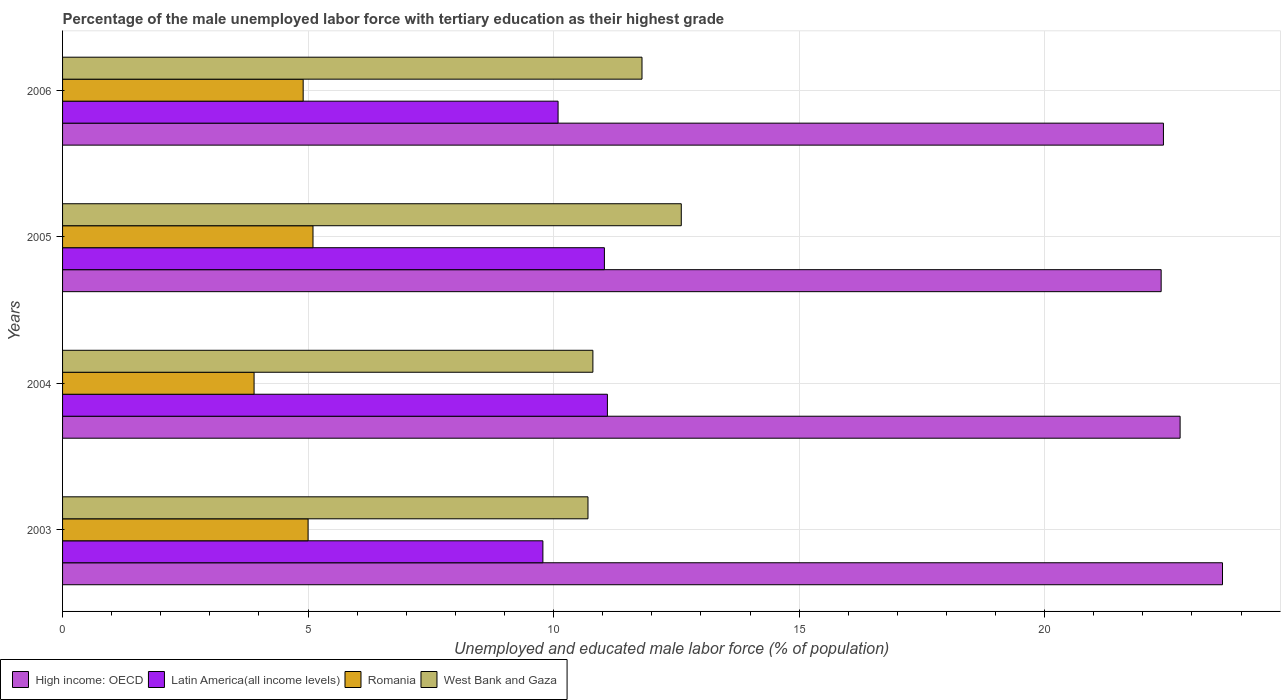How many different coloured bars are there?
Your response must be concise. 4. Are the number of bars per tick equal to the number of legend labels?
Provide a succinct answer. Yes. How many bars are there on the 1st tick from the top?
Your answer should be compact. 4. How many bars are there on the 1st tick from the bottom?
Make the answer very short. 4. What is the label of the 3rd group of bars from the top?
Offer a terse response. 2004. In how many cases, is the number of bars for a given year not equal to the number of legend labels?
Offer a terse response. 0. What is the percentage of the unemployed male labor force with tertiary education in High income: OECD in 2005?
Your answer should be compact. 22.37. Across all years, what is the maximum percentage of the unemployed male labor force with tertiary education in West Bank and Gaza?
Ensure brevity in your answer.  12.6. Across all years, what is the minimum percentage of the unemployed male labor force with tertiary education in Latin America(all income levels)?
Keep it short and to the point. 9.78. In which year was the percentage of the unemployed male labor force with tertiary education in High income: OECD minimum?
Ensure brevity in your answer.  2005. What is the total percentage of the unemployed male labor force with tertiary education in Latin America(all income levels) in the graph?
Give a very brief answer. 42. What is the difference between the percentage of the unemployed male labor force with tertiary education in West Bank and Gaza in 2003 and that in 2004?
Ensure brevity in your answer.  -0.1. What is the difference between the percentage of the unemployed male labor force with tertiary education in High income: OECD in 2004 and the percentage of the unemployed male labor force with tertiary education in West Bank and Gaza in 2005?
Your answer should be compact. 10.16. What is the average percentage of the unemployed male labor force with tertiary education in Latin America(all income levels) per year?
Make the answer very short. 10.5. In the year 2006, what is the difference between the percentage of the unemployed male labor force with tertiary education in West Bank and Gaza and percentage of the unemployed male labor force with tertiary education in High income: OECD?
Give a very brief answer. -10.62. In how many years, is the percentage of the unemployed male labor force with tertiary education in Latin America(all income levels) greater than 6 %?
Give a very brief answer. 4. What is the ratio of the percentage of the unemployed male labor force with tertiary education in Romania in 2005 to that in 2006?
Keep it short and to the point. 1.04. Is the percentage of the unemployed male labor force with tertiary education in High income: OECD in 2003 less than that in 2005?
Provide a short and direct response. No. Is the difference between the percentage of the unemployed male labor force with tertiary education in West Bank and Gaza in 2003 and 2005 greater than the difference between the percentage of the unemployed male labor force with tertiary education in High income: OECD in 2003 and 2005?
Keep it short and to the point. No. What is the difference between the highest and the second highest percentage of the unemployed male labor force with tertiary education in West Bank and Gaza?
Your response must be concise. 0.8. What is the difference between the highest and the lowest percentage of the unemployed male labor force with tertiary education in Romania?
Provide a short and direct response. 1.2. In how many years, is the percentage of the unemployed male labor force with tertiary education in High income: OECD greater than the average percentage of the unemployed male labor force with tertiary education in High income: OECD taken over all years?
Your response must be concise. 1. Is the sum of the percentage of the unemployed male labor force with tertiary education in Romania in 2003 and 2004 greater than the maximum percentage of the unemployed male labor force with tertiary education in Latin America(all income levels) across all years?
Your response must be concise. No. Is it the case that in every year, the sum of the percentage of the unemployed male labor force with tertiary education in Latin America(all income levels) and percentage of the unemployed male labor force with tertiary education in High income: OECD is greater than the sum of percentage of the unemployed male labor force with tertiary education in Romania and percentage of the unemployed male labor force with tertiary education in West Bank and Gaza?
Provide a short and direct response. No. What does the 3rd bar from the top in 2003 represents?
Give a very brief answer. Latin America(all income levels). What does the 2nd bar from the bottom in 2003 represents?
Ensure brevity in your answer.  Latin America(all income levels). Is it the case that in every year, the sum of the percentage of the unemployed male labor force with tertiary education in Romania and percentage of the unemployed male labor force with tertiary education in High income: OECD is greater than the percentage of the unemployed male labor force with tertiary education in Latin America(all income levels)?
Your response must be concise. Yes. Are all the bars in the graph horizontal?
Make the answer very short. Yes. How many years are there in the graph?
Keep it short and to the point. 4. What is the difference between two consecutive major ticks on the X-axis?
Provide a succinct answer. 5. Are the values on the major ticks of X-axis written in scientific E-notation?
Ensure brevity in your answer.  No. Does the graph contain any zero values?
Offer a terse response. No. Does the graph contain grids?
Offer a terse response. Yes. What is the title of the graph?
Make the answer very short. Percentage of the male unemployed labor force with tertiary education as their highest grade. Does "Sub-Saharan Africa (all income levels)" appear as one of the legend labels in the graph?
Your answer should be very brief. No. What is the label or title of the X-axis?
Keep it short and to the point. Unemployed and educated male labor force (% of population). What is the label or title of the Y-axis?
Ensure brevity in your answer.  Years. What is the Unemployed and educated male labor force (% of population) in High income: OECD in 2003?
Offer a very short reply. 23.62. What is the Unemployed and educated male labor force (% of population) in Latin America(all income levels) in 2003?
Keep it short and to the point. 9.78. What is the Unemployed and educated male labor force (% of population) in West Bank and Gaza in 2003?
Offer a terse response. 10.7. What is the Unemployed and educated male labor force (% of population) in High income: OECD in 2004?
Offer a terse response. 22.76. What is the Unemployed and educated male labor force (% of population) of Latin America(all income levels) in 2004?
Your answer should be very brief. 11.1. What is the Unemployed and educated male labor force (% of population) of Romania in 2004?
Your answer should be compact. 3.9. What is the Unemployed and educated male labor force (% of population) of West Bank and Gaza in 2004?
Your response must be concise. 10.8. What is the Unemployed and educated male labor force (% of population) in High income: OECD in 2005?
Provide a short and direct response. 22.37. What is the Unemployed and educated male labor force (% of population) in Latin America(all income levels) in 2005?
Give a very brief answer. 11.03. What is the Unemployed and educated male labor force (% of population) in Romania in 2005?
Your answer should be compact. 5.1. What is the Unemployed and educated male labor force (% of population) in West Bank and Gaza in 2005?
Your answer should be very brief. 12.6. What is the Unemployed and educated male labor force (% of population) of High income: OECD in 2006?
Provide a short and direct response. 22.42. What is the Unemployed and educated male labor force (% of population) in Latin America(all income levels) in 2006?
Ensure brevity in your answer.  10.09. What is the Unemployed and educated male labor force (% of population) in Romania in 2006?
Provide a short and direct response. 4.9. What is the Unemployed and educated male labor force (% of population) in West Bank and Gaza in 2006?
Offer a very short reply. 11.8. Across all years, what is the maximum Unemployed and educated male labor force (% of population) of High income: OECD?
Offer a very short reply. 23.62. Across all years, what is the maximum Unemployed and educated male labor force (% of population) in Latin America(all income levels)?
Your response must be concise. 11.1. Across all years, what is the maximum Unemployed and educated male labor force (% of population) of Romania?
Offer a very short reply. 5.1. Across all years, what is the maximum Unemployed and educated male labor force (% of population) in West Bank and Gaza?
Your answer should be very brief. 12.6. Across all years, what is the minimum Unemployed and educated male labor force (% of population) in High income: OECD?
Your response must be concise. 22.37. Across all years, what is the minimum Unemployed and educated male labor force (% of population) in Latin America(all income levels)?
Offer a terse response. 9.78. Across all years, what is the minimum Unemployed and educated male labor force (% of population) in Romania?
Provide a short and direct response. 3.9. Across all years, what is the minimum Unemployed and educated male labor force (% of population) in West Bank and Gaza?
Provide a short and direct response. 10.7. What is the total Unemployed and educated male labor force (% of population) in High income: OECD in the graph?
Keep it short and to the point. 91.17. What is the total Unemployed and educated male labor force (% of population) of Latin America(all income levels) in the graph?
Your answer should be compact. 42. What is the total Unemployed and educated male labor force (% of population) in West Bank and Gaza in the graph?
Keep it short and to the point. 45.9. What is the difference between the Unemployed and educated male labor force (% of population) in High income: OECD in 2003 and that in 2004?
Offer a very short reply. 0.86. What is the difference between the Unemployed and educated male labor force (% of population) in Latin America(all income levels) in 2003 and that in 2004?
Make the answer very short. -1.31. What is the difference between the Unemployed and educated male labor force (% of population) of Romania in 2003 and that in 2004?
Your response must be concise. 1.1. What is the difference between the Unemployed and educated male labor force (% of population) in High income: OECD in 2003 and that in 2005?
Your answer should be very brief. 1.25. What is the difference between the Unemployed and educated male labor force (% of population) of Latin America(all income levels) in 2003 and that in 2005?
Provide a short and direct response. -1.25. What is the difference between the Unemployed and educated male labor force (% of population) of Romania in 2003 and that in 2005?
Ensure brevity in your answer.  -0.1. What is the difference between the Unemployed and educated male labor force (% of population) of West Bank and Gaza in 2003 and that in 2005?
Give a very brief answer. -1.9. What is the difference between the Unemployed and educated male labor force (% of population) in High income: OECD in 2003 and that in 2006?
Your response must be concise. 1.2. What is the difference between the Unemployed and educated male labor force (% of population) of Latin America(all income levels) in 2003 and that in 2006?
Provide a succinct answer. -0.31. What is the difference between the Unemployed and educated male labor force (% of population) of Romania in 2003 and that in 2006?
Your response must be concise. 0.1. What is the difference between the Unemployed and educated male labor force (% of population) in High income: OECD in 2004 and that in 2005?
Provide a succinct answer. 0.39. What is the difference between the Unemployed and educated male labor force (% of population) in Latin America(all income levels) in 2004 and that in 2005?
Keep it short and to the point. 0.06. What is the difference between the Unemployed and educated male labor force (% of population) of Romania in 2004 and that in 2005?
Provide a succinct answer. -1.2. What is the difference between the Unemployed and educated male labor force (% of population) of High income: OECD in 2004 and that in 2006?
Provide a succinct answer. 0.34. What is the difference between the Unemployed and educated male labor force (% of population) in Romania in 2004 and that in 2006?
Provide a succinct answer. -1. What is the difference between the Unemployed and educated male labor force (% of population) of West Bank and Gaza in 2004 and that in 2006?
Your answer should be very brief. -1. What is the difference between the Unemployed and educated male labor force (% of population) of High income: OECD in 2005 and that in 2006?
Ensure brevity in your answer.  -0.05. What is the difference between the Unemployed and educated male labor force (% of population) in Latin America(all income levels) in 2005 and that in 2006?
Give a very brief answer. 0.94. What is the difference between the Unemployed and educated male labor force (% of population) of Romania in 2005 and that in 2006?
Offer a terse response. 0.2. What is the difference between the Unemployed and educated male labor force (% of population) of West Bank and Gaza in 2005 and that in 2006?
Your answer should be compact. 0.8. What is the difference between the Unemployed and educated male labor force (% of population) of High income: OECD in 2003 and the Unemployed and educated male labor force (% of population) of Latin America(all income levels) in 2004?
Offer a very short reply. 12.53. What is the difference between the Unemployed and educated male labor force (% of population) in High income: OECD in 2003 and the Unemployed and educated male labor force (% of population) in Romania in 2004?
Your answer should be very brief. 19.72. What is the difference between the Unemployed and educated male labor force (% of population) in High income: OECD in 2003 and the Unemployed and educated male labor force (% of population) in West Bank and Gaza in 2004?
Offer a terse response. 12.82. What is the difference between the Unemployed and educated male labor force (% of population) of Latin America(all income levels) in 2003 and the Unemployed and educated male labor force (% of population) of Romania in 2004?
Offer a terse response. 5.88. What is the difference between the Unemployed and educated male labor force (% of population) of Latin America(all income levels) in 2003 and the Unemployed and educated male labor force (% of population) of West Bank and Gaza in 2004?
Your answer should be compact. -1.02. What is the difference between the Unemployed and educated male labor force (% of population) of High income: OECD in 2003 and the Unemployed and educated male labor force (% of population) of Latin America(all income levels) in 2005?
Offer a terse response. 12.59. What is the difference between the Unemployed and educated male labor force (% of population) in High income: OECD in 2003 and the Unemployed and educated male labor force (% of population) in Romania in 2005?
Offer a terse response. 18.52. What is the difference between the Unemployed and educated male labor force (% of population) of High income: OECD in 2003 and the Unemployed and educated male labor force (% of population) of West Bank and Gaza in 2005?
Your answer should be very brief. 11.02. What is the difference between the Unemployed and educated male labor force (% of population) of Latin America(all income levels) in 2003 and the Unemployed and educated male labor force (% of population) of Romania in 2005?
Offer a terse response. 4.68. What is the difference between the Unemployed and educated male labor force (% of population) in Latin America(all income levels) in 2003 and the Unemployed and educated male labor force (% of population) in West Bank and Gaza in 2005?
Your response must be concise. -2.82. What is the difference between the Unemployed and educated male labor force (% of population) of Romania in 2003 and the Unemployed and educated male labor force (% of population) of West Bank and Gaza in 2005?
Offer a terse response. -7.6. What is the difference between the Unemployed and educated male labor force (% of population) of High income: OECD in 2003 and the Unemployed and educated male labor force (% of population) of Latin America(all income levels) in 2006?
Your response must be concise. 13.53. What is the difference between the Unemployed and educated male labor force (% of population) in High income: OECD in 2003 and the Unemployed and educated male labor force (% of population) in Romania in 2006?
Your answer should be compact. 18.72. What is the difference between the Unemployed and educated male labor force (% of population) of High income: OECD in 2003 and the Unemployed and educated male labor force (% of population) of West Bank and Gaza in 2006?
Ensure brevity in your answer.  11.82. What is the difference between the Unemployed and educated male labor force (% of population) in Latin America(all income levels) in 2003 and the Unemployed and educated male labor force (% of population) in Romania in 2006?
Ensure brevity in your answer.  4.88. What is the difference between the Unemployed and educated male labor force (% of population) of Latin America(all income levels) in 2003 and the Unemployed and educated male labor force (% of population) of West Bank and Gaza in 2006?
Provide a short and direct response. -2.02. What is the difference between the Unemployed and educated male labor force (% of population) of High income: OECD in 2004 and the Unemployed and educated male labor force (% of population) of Latin America(all income levels) in 2005?
Ensure brevity in your answer.  11.72. What is the difference between the Unemployed and educated male labor force (% of population) in High income: OECD in 2004 and the Unemployed and educated male labor force (% of population) in Romania in 2005?
Provide a succinct answer. 17.66. What is the difference between the Unemployed and educated male labor force (% of population) in High income: OECD in 2004 and the Unemployed and educated male labor force (% of population) in West Bank and Gaza in 2005?
Your response must be concise. 10.16. What is the difference between the Unemployed and educated male labor force (% of population) of Latin America(all income levels) in 2004 and the Unemployed and educated male labor force (% of population) of Romania in 2005?
Your answer should be compact. 6. What is the difference between the Unemployed and educated male labor force (% of population) in Latin America(all income levels) in 2004 and the Unemployed and educated male labor force (% of population) in West Bank and Gaza in 2005?
Provide a succinct answer. -1.5. What is the difference between the Unemployed and educated male labor force (% of population) in High income: OECD in 2004 and the Unemployed and educated male labor force (% of population) in Latin America(all income levels) in 2006?
Offer a very short reply. 12.67. What is the difference between the Unemployed and educated male labor force (% of population) of High income: OECD in 2004 and the Unemployed and educated male labor force (% of population) of Romania in 2006?
Offer a terse response. 17.86. What is the difference between the Unemployed and educated male labor force (% of population) of High income: OECD in 2004 and the Unemployed and educated male labor force (% of population) of West Bank and Gaza in 2006?
Provide a succinct answer. 10.96. What is the difference between the Unemployed and educated male labor force (% of population) of Latin America(all income levels) in 2004 and the Unemployed and educated male labor force (% of population) of Romania in 2006?
Your answer should be very brief. 6.2. What is the difference between the Unemployed and educated male labor force (% of population) of Latin America(all income levels) in 2004 and the Unemployed and educated male labor force (% of population) of West Bank and Gaza in 2006?
Your answer should be compact. -0.7. What is the difference between the Unemployed and educated male labor force (% of population) of Romania in 2004 and the Unemployed and educated male labor force (% of population) of West Bank and Gaza in 2006?
Make the answer very short. -7.9. What is the difference between the Unemployed and educated male labor force (% of population) of High income: OECD in 2005 and the Unemployed and educated male labor force (% of population) of Latin America(all income levels) in 2006?
Your response must be concise. 12.28. What is the difference between the Unemployed and educated male labor force (% of population) in High income: OECD in 2005 and the Unemployed and educated male labor force (% of population) in Romania in 2006?
Ensure brevity in your answer.  17.47. What is the difference between the Unemployed and educated male labor force (% of population) of High income: OECD in 2005 and the Unemployed and educated male labor force (% of population) of West Bank and Gaza in 2006?
Offer a very short reply. 10.57. What is the difference between the Unemployed and educated male labor force (% of population) in Latin America(all income levels) in 2005 and the Unemployed and educated male labor force (% of population) in Romania in 2006?
Your response must be concise. 6.13. What is the difference between the Unemployed and educated male labor force (% of population) of Latin America(all income levels) in 2005 and the Unemployed and educated male labor force (% of population) of West Bank and Gaza in 2006?
Offer a terse response. -0.77. What is the average Unemployed and educated male labor force (% of population) of High income: OECD per year?
Provide a short and direct response. 22.79. What is the average Unemployed and educated male labor force (% of population) of Latin America(all income levels) per year?
Your answer should be compact. 10.5. What is the average Unemployed and educated male labor force (% of population) in Romania per year?
Keep it short and to the point. 4.72. What is the average Unemployed and educated male labor force (% of population) of West Bank and Gaza per year?
Provide a succinct answer. 11.47. In the year 2003, what is the difference between the Unemployed and educated male labor force (% of population) of High income: OECD and Unemployed and educated male labor force (% of population) of Latin America(all income levels)?
Your answer should be very brief. 13.84. In the year 2003, what is the difference between the Unemployed and educated male labor force (% of population) of High income: OECD and Unemployed and educated male labor force (% of population) of Romania?
Give a very brief answer. 18.62. In the year 2003, what is the difference between the Unemployed and educated male labor force (% of population) of High income: OECD and Unemployed and educated male labor force (% of population) of West Bank and Gaza?
Ensure brevity in your answer.  12.92. In the year 2003, what is the difference between the Unemployed and educated male labor force (% of population) of Latin America(all income levels) and Unemployed and educated male labor force (% of population) of Romania?
Provide a succinct answer. 4.78. In the year 2003, what is the difference between the Unemployed and educated male labor force (% of population) in Latin America(all income levels) and Unemployed and educated male labor force (% of population) in West Bank and Gaza?
Provide a short and direct response. -0.92. In the year 2003, what is the difference between the Unemployed and educated male labor force (% of population) of Romania and Unemployed and educated male labor force (% of population) of West Bank and Gaza?
Give a very brief answer. -5.7. In the year 2004, what is the difference between the Unemployed and educated male labor force (% of population) in High income: OECD and Unemployed and educated male labor force (% of population) in Latin America(all income levels)?
Your response must be concise. 11.66. In the year 2004, what is the difference between the Unemployed and educated male labor force (% of population) of High income: OECD and Unemployed and educated male labor force (% of population) of Romania?
Keep it short and to the point. 18.86. In the year 2004, what is the difference between the Unemployed and educated male labor force (% of population) in High income: OECD and Unemployed and educated male labor force (% of population) in West Bank and Gaza?
Provide a succinct answer. 11.96. In the year 2004, what is the difference between the Unemployed and educated male labor force (% of population) of Latin America(all income levels) and Unemployed and educated male labor force (% of population) of Romania?
Your answer should be compact. 7.2. In the year 2004, what is the difference between the Unemployed and educated male labor force (% of population) of Latin America(all income levels) and Unemployed and educated male labor force (% of population) of West Bank and Gaza?
Offer a terse response. 0.3. In the year 2005, what is the difference between the Unemployed and educated male labor force (% of population) in High income: OECD and Unemployed and educated male labor force (% of population) in Latin America(all income levels)?
Provide a short and direct response. 11.34. In the year 2005, what is the difference between the Unemployed and educated male labor force (% of population) of High income: OECD and Unemployed and educated male labor force (% of population) of Romania?
Make the answer very short. 17.27. In the year 2005, what is the difference between the Unemployed and educated male labor force (% of population) in High income: OECD and Unemployed and educated male labor force (% of population) in West Bank and Gaza?
Ensure brevity in your answer.  9.77. In the year 2005, what is the difference between the Unemployed and educated male labor force (% of population) in Latin America(all income levels) and Unemployed and educated male labor force (% of population) in Romania?
Your answer should be very brief. 5.93. In the year 2005, what is the difference between the Unemployed and educated male labor force (% of population) in Latin America(all income levels) and Unemployed and educated male labor force (% of population) in West Bank and Gaza?
Your answer should be compact. -1.57. In the year 2005, what is the difference between the Unemployed and educated male labor force (% of population) of Romania and Unemployed and educated male labor force (% of population) of West Bank and Gaza?
Keep it short and to the point. -7.5. In the year 2006, what is the difference between the Unemployed and educated male labor force (% of population) of High income: OECD and Unemployed and educated male labor force (% of population) of Latin America(all income levels)?
Provide a short and direct response. 12.33. In the year 2006, what is the difference between the Unemployed and educated male labor force (% of population) in High income: OECD and Unemployed and educated male labor force (% of population) in Romania?
Offer a very short reply. 17.52. In the year 2006, what is the difference between the Unemployed and educated male labor force (% of population) in High income: OECD and Unemployed and educated male labor force (% of population) in West Bank and Gaza?
Provide a short and direct response. 10.62. In the year 2006, what is the difference between the Unemployed and educated male labor force (% of population) in Latin America(all income levels) and Unemployed and educated male labor force (% of population) in Romania?
Provide a short and direct response. 5.19. In the year 2006, what is the difference between the Unemployed and educated male labor force (% of population) of Latin America(all income levels) and Unemployed and educated male labor force (% of population) of West Bank and Gaza?
Offer a terse response. -1.71. In the year 2006, what is the difference between the Unemployed and educated male labor force (% of population) in Romania and Unemployed and educated male labor force (% of population) in West Bank and Gaza?
Your answer should be very brief. -6.9. What is the ratio of the Unemployed and educated male labor force (% of population) in High income: OECD in 2003 to that in 2004?
Your response must be concise. 1.04. What is the ratio of the Unemployed and educated male labor force (% of population) of Latin America(all income levels) in 2003 to that in 2004?
Keep it short and to the point. 0.88. What is the ratio of the Unemployed and educated male labor force (% of population) in Romania in 2003 to that in 2004?
Keep it short and to the point. 1.28. What is the ratio of the Unemployed and educated male labor force (% of population) in West Bank and Gaza in 2003 to that in 2004?
Your answer should be compact. 0.99. What is the ratio of the Unemployed and educated male labor force (% of population) of High income: OECD in 2003 to that in 2005?
Offer a terse response. 1.06. What is the ratio of the Unemployed and educated male labor force (% of population) in Latin America(all income levels) in 2003 to that in 2005?
Provide a succinct answer. 0.89. What is the ratio of the Unemployed and educated male labor force (% of population) of Romania in 2003 to that in 2005?
Provide a short and direct response. 0.98. What is the ratio of the Unemployed and educated male labor force (% of population) in West Bank and Gaza in 2003 to that in 2005?
Your answer should be compact. 0.85. What is the ratio of the Unemployed and educated male labor force (% of population) in High income: OECD in 2003 to that in 2006?
Offer a very short reply. 1.05. What is the ratio of the Unemployed and educated male labor force (% of population) of Latin America(all income levels) in 2003 to that in 2006?
Ensure brevity in your answer.  0.97. What is the ratio of the Unemployed and educated male labor force (% of population) in Romania in 2003 to that in 2006?
Give a very brief answer. 1.02. What is the ratio of the Unemployed and educated male labor force (% of population) in West Bank and Gaza in 2003 to that in 2006?
Provide a succinct answer. 0.91. What is the ratio of the Unemployed and educated male labor force (% of population) of High income: OECD in 2004 to that in 2005?
Offer a terse response. 1.02. What is the ratio of the Unemployed and educated male labor force (% of population) of Latin America(all income levels) in 2004 to that in 2005?
Give a very brief answer. 1.01. What is the ratio of the Unemployed and educated male labor force (% of population) in Romania in 2004 to that in 2005?
Provide a succinct answer. 0.76. What is the ratio of the Unemployed and educated male labor force (% of population) of High income: OECD in 2004 to that in 2006?
Ensure brevity in your answer.  1.02. What is the ratio of the Unemployed and educated male labor force (% of population) of Latin America(all income levels) in 2004 to that in 2006?
Provide a succinct answer. 1.1. What is the ratio of the Unemployed and educated male labor force (% of population) in Romania in 2004 to that in 2006?
Ensure brevity in your answer.  0.8. What is the ratio of the Unemployed and educated male labor force (% of population) of West Bank and Gaza in 2004 to that in 2006?
Offer a very short reply. 0.92. What is the ratio of the Unemployed and educated male labor force (% of population) in Latin America(all income levels) in 2005 to that in 2006?
Your answer should be very brief. 1.09. What is the ratio of the Unemployed and educated male labor force (% of population) in Romania in 2005 to that in 2006?
Provide a succinct answer. 1.04. What is the ratio of the Unemployed and educated male labor force (% of population) of West Bank and Gaza in 2005 to that in 2006?
Keep it short and to the point. 1.07. What is the difference between the highest and the second highest Unemployed and educated male labor force (% of population) of High income: OECD?
Provide a succinct answer. 0.86. What is the difference between the highest and the second highest Unemployed and educated male labor force (% of population) of Latin America(all income levels)?
Provide a short and direct response. 0.06. What is the difference between the highest and the second highest Unemployed and educated male labor force (% of population) of Romania?
Your response must be concise. 0.1. What is the difference between the highest and the second highest Unemployed and educated male labor force (% of population) of West Bank and Gaza?
Your response must be concise. 0.8. What is the difference between the highest and the lowest Unemployed and educated male labor force (% of population) of High income: OECD?
Ensure brevity in your answer.  1.25. What is the difference between the highest and the lowest Unemployed and educated male labor force (% of population) in Latin America(all income levels)?
Make the answer very short. 1.31. 